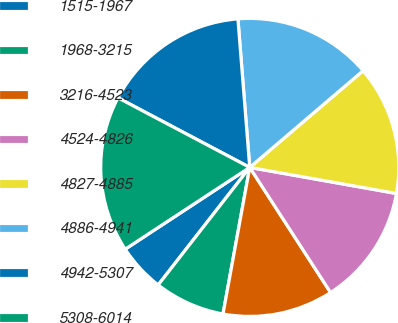Convert chart. <chart><loc_0><loc_0><loc_500><loc_500><pie_chart><fcel>1515-1967<fcel>1968-3215<fcel>3216-4523<fcel>4524-4826<fcel>4827-4885<fcel>4886-4941<fcel>4942-5307<fcel>5308-6014<nl><fcel>5.22%<fcel>7.66%<fcel>12.0%<fcel>13.07%<fcel>14.04%<fcel>15.02%<fcel>16.0%<fcel>16.98%<nl></chart> 